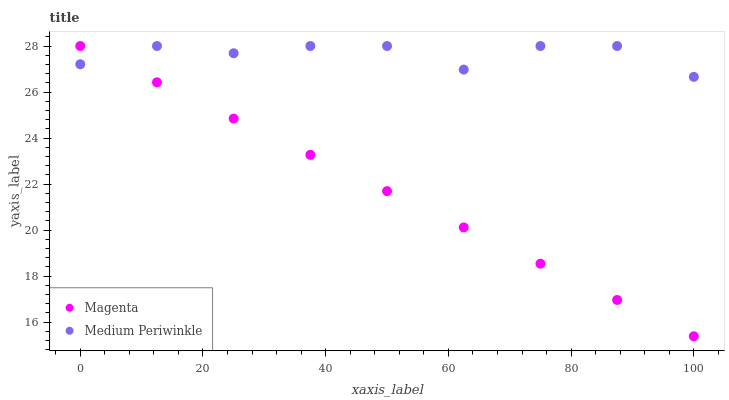Does Magenta have the minimum area under the curve?
Answer yes or no. Yes. Does Medium Periwinkle have the maximum area under the curve?
Answer yes or no. Yes. Does Medium Periwinkle have the minimum area under the curve?
Answer yes or no. No. Is Magenta the smoothest?
Answer yes or no. Yes. Is Medium Periwinkle the roughest?
Answer yes or no. Yes. Is Medium Periwinkle the smoothest?
Answer yes or no. No. Does Magenta have the lowest value?
Answer yes or no. Yes. Does Medium Periwinkle have the lowest value?
Answer yes or no. No. Does Medium Periwinkle have the highest value?
Answer yes or no. Yes. Does Medium Periwinkle intersect Magenta?
Answer yes or no. Yes. Is Medium Periwinkle less than Magenta?
Answer yes or no. No. Is Medium Periwinkle greater than Magenta?
Answer yes or no. No. 